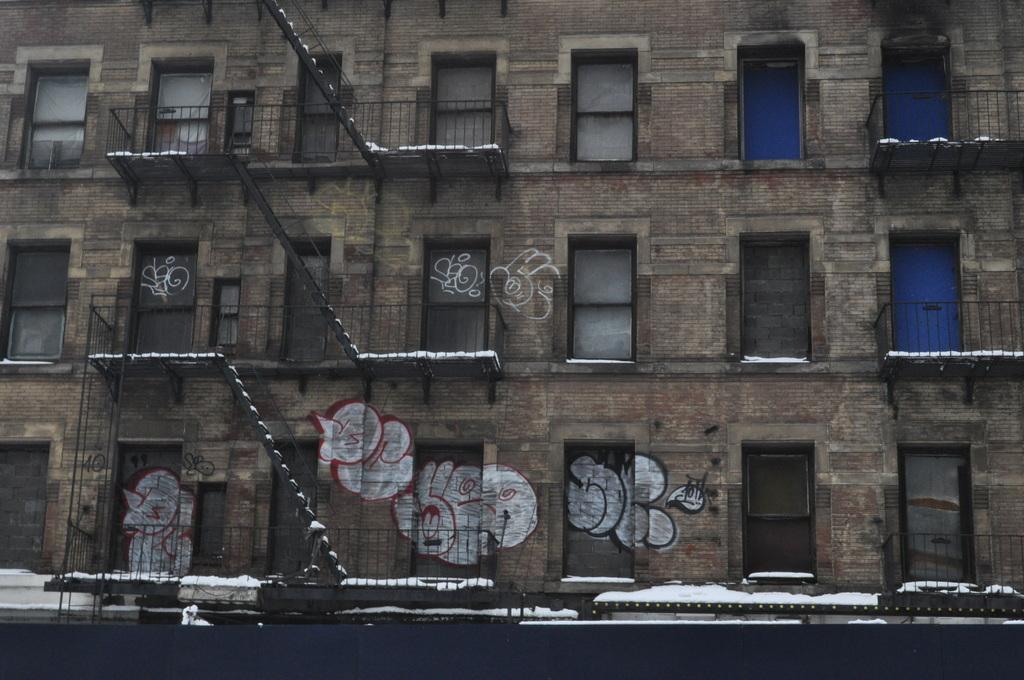How would you summarize this image in a sentence or two? In this image we can see a building. On the building we can see a stairs, windows and snow. We can see a painting on the building. 